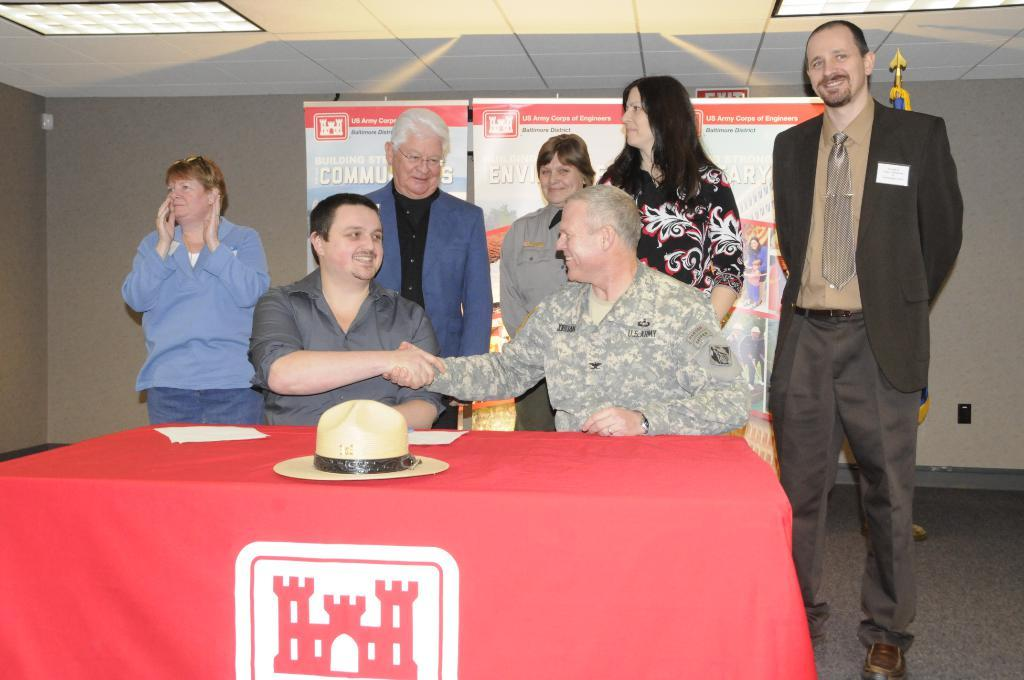How many people are in the image? There are two men in the image. What are the men doing in the image? The men are sitting on chairs. What object is on the table in the image? There is a hat on the table. Can you describe the people standing in the background of the image? There are people standing at the back of the image. What type of stick is being used by the men in the image? There is no stick present in the image. What year is depicted in the image? The image does not depict a specific year; it is a snapshot of a moment in time. 